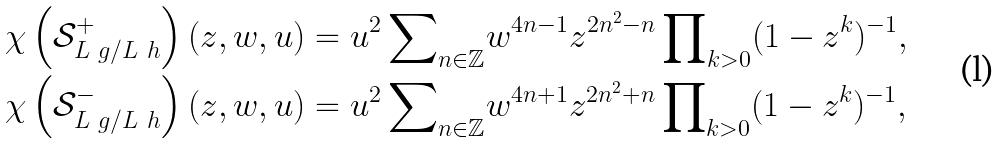Convert formula to latex. <formula><loc_0><loc_0><loc_500><loc_500>\chi \left ( \mathcal { S } _ { L \ g / L \ h } ^ { + } \right ) ( z , w , u ) & = u ^ { 2 } \, { \sum } _ { n \in \mathbb { Z } } w ^ { 4 n - 1 } z ^ { 2 n ^ { 2 } - n } \, { \prod } _ { k > 0 } ( 1 - z ^ { k } ) ^ { - 1 } , \\ \chi \left ( \mathcal { S } _ { L \ g / L \ h } ^ { - } \right ) ( z , w , u ) & = u ^ { 2 } \, { \sum } _ { n \in \mathbb { Z } } w ^ { 4 n + 1 } z ^ { 2 n ^ { 2 } + n } \, { \prod } _ { k > 0 } ( 1 - z ^ { k } ) ^ { - 1 } ,</formula> 